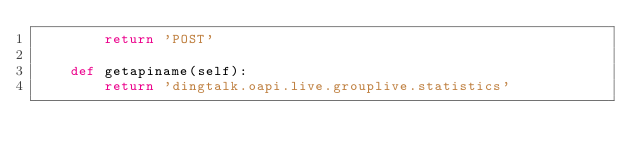<code> <loc_0><loc_0><loc_500><loc_500><_Python_>		return 'POST'

	def getapiname(self):
		return 'dingtalk.oapi.live.grouplive.statistics'
</code> 